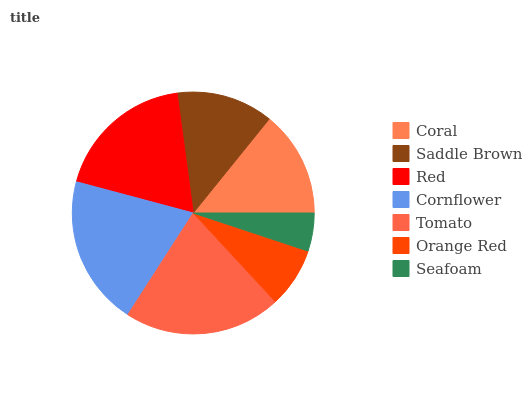Is Seafoam the minimum?
Answer yes or no. Yes. Is Tomato the maximum?
Answer yes or no. Yes. Is Saddle Brown the minimum?
Answer yes or no. No. Is Saddle Brown the maximum?
Answer yes or no. No. Is Coral greater than Saddle Brown?
Answer yes or no. Yes. Is Saddle Brown less than Coral?
Answer yes or no. Yes. Is Saddle Brown greater than Coral?
Answer yes or no. No. Is Coral less than Saddle Brown?
Answer yes or no. No. Is Coral the high median?
Answer yes or no. Yes. Is Coral the low median?
Answer yes or no. Yes. Is Tomato the high median?
Answer yes or no. No. Is Orange Red the low median?
Answer yes or no. No. 